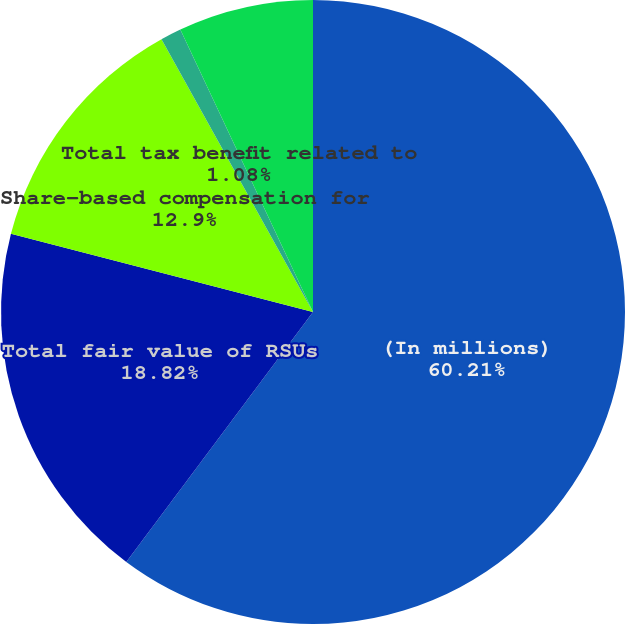Convert chart. <chart><loc_0><loc_0><loc_500><loc_500><pie_chart><fcel>(In millions)<fcel>Total fair value of RSUs<fcel>Share-based compensation for<fcel>Total tax benefit related to<fcel>Cash tax benefits realized for<nl><fcel>60.21%<fcel>18.82%<fcel>12.9%<fcel>1.08%<fcel>6.99%<nl></chart> 